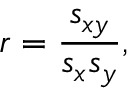Convert formula to latex. <formula><loc_0><loc_0><loc_500><loc_500>r = \frac { s _ { x y } } { s _ { x } s _ { y } } ,</formula> 